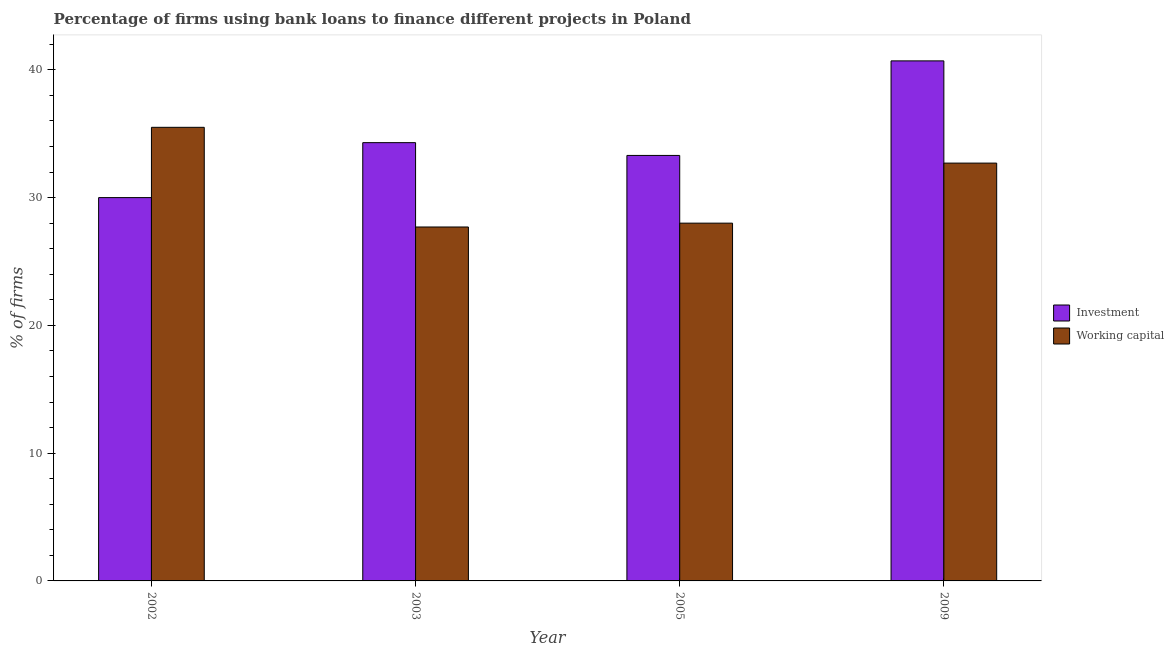How many different coloured bars are there?
Your answer should be very brief. 2. How many groups of bars are there?
Your answer should be very brief. 4. Are the number of bars per tick equal to the number of legend labels?
Ensure brevity in your answer.  Yes. How many bars are there on the 3rd tick from the left?
Offer a terse response. 2. In how many cases, is the number of bars for a given year not equal to the number of legend labels?
Give a very brief answer. 0. What is the percentage of firms using banks to finance investment in 2005?
Ensure brevity in your answer.  33.3. Across all years, what is the maximum percentage of firms using banks to finance working capital?
Provide a succinct answer. 35.5. In which year was the percentage of firms using banks to finance investment maximum?
Give a very brief answer. 2009. What is the total percentage of firms using banks to finance investment in the graph?
Ensure brevity in your answer.  138.3. What is the difference between the percentage of firms using banks to finance working capital in 2003 and that in 2009?
Your answer should be compact. -5. What is the average percentage of firms using banks to finance working capital per year?
Offer a very short reply. 30.98. In the year 2005, what is the difference between the percentage of firms using banks to finance investment and percentage of firms using banks to finance working capital?
Give a very brief answer. 0. In how many years, is the percentage of firms using banks to finance investment greater than 28 %?
Your answer should be compact. 4. What is the ratio of the percentage of firms using banks to finance investment in 2003 to that in 2005?
Offer a very short reply. 1.03. Is the percentage of firms using banks to finance investment in 2003 less than that in 2009?
Your answer should be compact. Yes. Is the difference between the percentage of firms using banks to finance investment in 2003 and 2005 greater than the difference between the percentage of firms using banks to finance working capital in 2003 and 2005?
Give a very brief answer. No. What is the difference between the highest and the second highest percentage of firms using banks to finance working capital?
Give a very brief answer. 2.8. What is the difference between the highest and the lowest percentage of firms using banks to finance investment?
Ensure brevity in your answer.  10.7. What does the 1st bar from the left in 2005 represents?
Your response must be concise. Investment. What does the 2nd bar from the right in 2005 represents?
Your response must be concise. Investment. How many bars are there?
Make the answer very short. 8. Are all the bars in the graph horizontal?
Your answer should be compact. No. How many years are there in the graph?
Make the answer very short. 4. Does the graph contain any zero values?
Provide a short and direct response. No. How many legend labels are there?
Offer a terse response. 2. What is the title of the graph?
Provide a short and direct response. Percentage of firms using bank loans to finance different projects in Poland. What is the label or title of the Y-axis?
Make the answer very short. % of firms. What is the % of firms in Working capital in 2002?
Your answer should be compact. 35.5. What is the % of firms of Investment in 2003?
Your answer should be very brief. 34.3. What is the % of firms of Working capital in 2003?
Ensure brevity in your answer.  27.7. What is the % of firms of Investment in 2005?
Provide a short and direct response. 33.3. What is the % of firms of Working capital in 2005?
Ensure brevity in your answer.  28. What is the % of firms of Investment in 2009?
Offer a very short reply. 40.7. What is the % of firms in Working capital in 2009?
Offer a terse response. 32.7. Across all years, what is the maximum % of firms of Investment?
Give a very brief answer. 40.7. Across all years, what is the maximum % of firms of Working capital?
Your answer should be very brief. 35.5. Across all years, what is the minimum % of firms in Investment?
Make the answer very short. 30. Across all years, what is the minimum % of firms in Working capital?
Your answer should be compact. 27.7. What is the total % of firms in Investment in the graph?
Offer a terse response. 138.3. What is the total % of firms in Working capital in the graph?
Offer a very short reply. 123.9. What is the difference between the % of firms in Investment in 2002 and that in 2003?
Provide a succinct answer. -4.3. What is the difference between the % of firms of Working capital in 2002 and that in 2009?
Your answer should be very brief. 2.8. What is the difference between the % of firms in Investment in 2003 and that in 2005?
Provide a succinct answer. 1. What is the difference between the % of firms in Working capital in 2003 and that in 2005?
Ensure brevity in your answer.  -0.3. What is the difference between the % of firms in Working capital in 2003 and that in 2009?
Your answer should be compact. -5. What is the difference between the % of firms in Investment in 2002 and the % of firms in Working capital in 2005?
Provide a succinct answer. 2. What is the difference between the % of firms of Investment in 2003 and the % of firms of Working capital in 2005?
Your answer should be very brief. 6.3. What is the difference between the % of firms of Investment in 2003 and the % of firms of Working capital in 2009?
Provide a succinct answer. 1.6. What is the average % of firms in Investment per year?
Offer a terse response. 34.58. What is the average % of firms in Working capital per year?
Ensure brevity in your answer.  30.98. In the year 2002, what is the difference between the % of firms of Investment and % of firms of Working capital?
Provide a succinct answer. -5.5. In the year 2005, what is the difference between the % of firms in Investment and % of firms in Working capital?
Give a very brief answer. 5.3. In the year 2009, what is the difference between the % of firms in Investment and % of firms in Working capital?
Provide a short and direct response. 8. What is the ratio of the % of firms of Investment in 2002 to that in 2003?
Give a very brief answer. 0.87. What is the ratio of the % of firms in Working capital in 2002 to that in 2003?
Your answer should be compact. 1.28. What is the ratio of the % of firms in Investment in 2002 to that in 2005?
Offer a very short reply. 0.9. What is the ratio of the % of firms of Working capital in 2002 to that in 2005?
Give a very brief answer. 1.27. What is the ratio of the % of firms in Investment in 2002 to that in 2009?
Your answer should be compact. 0.74. What is the ratio of the % of firms of Working capital in 2002 to that in 2009?
Provide a succinct answer. 1.09. What is the ratio of the % of firms of Investment in 2003 to that in 2005?
Your response must be concise. 1.03. What is the ratio of the % of firms of Working capital in 2003 to that in 2005?
Give a very brief answer. 0.99. What is the ratio of the % of firms in Investment in 2003 to that in 2009?
Keep it short and to the point. 0.84. What is the ratio of the % of firms of Working capital in 2003 to that in 2009?
Your answer should be compact. 0.85. What is the ratio of the % of firms of Investment in 2005 to that in 2009?
Ensure brevity in your answer.  0.82. What is the ratio of the % of firms of Working capital in 2005 to that in 2009?
Make the answer very short. 0.86. What is the difference between the highest and the second highest % of firms in Working capital?
Your answer should be compact. 2.8. What is the difference between the highest and the lowest % of firms of Investment?
Offer a very short reply. 10.7. 